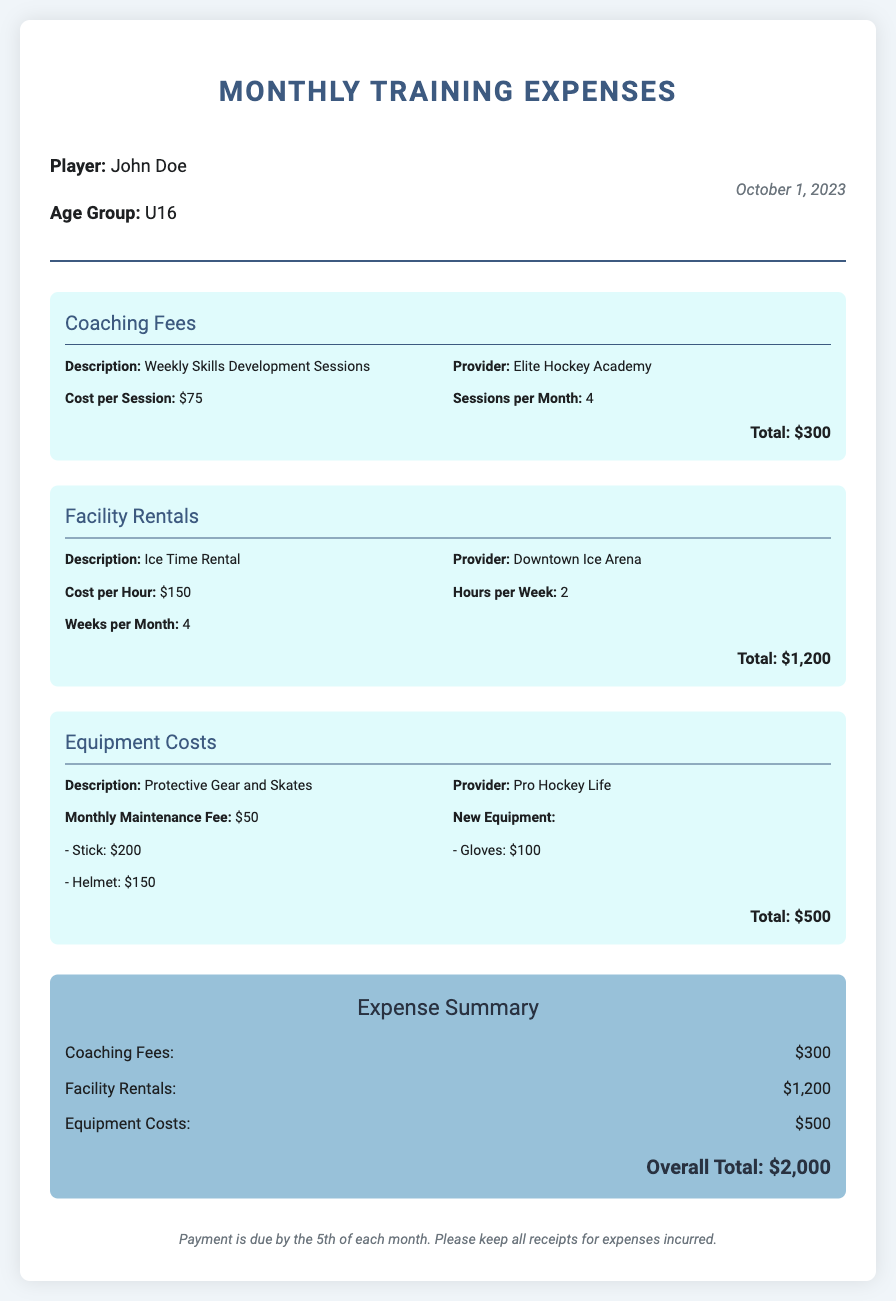What is the player’s name? The document states the player's name in the header section, which is John Doe.
Answer: John Doe What is the age group of the player? The age group is mentioned directly next to the player's name in the document, which is U16.
Answer: U16 What is the cost per session for coaching fees? The document specifies the cost per session for coaching fees as $75.
Answer: $75 How many coaching sessions are there per month? The document indicates that there are 4 coaching sessions per month.
Answer: 4 What is the total cost for facility rentals? The total cost for facility rentals is provided in the expense section as $1,200.
Answer: $1,200 Which provider offers the ice time rental? The document lists Downtown Ice Arena as the provider for ice time rental.
Answer: Downtown Ice Arena What are the monthly maintenance fees for equipment? The document mentions that the monthly maintenance fee for equipment is $50.
Answer: $50 What is the overall total of all expenses? The overall total is calculated and stated in the summary section as $2,000.
Answer: $2,000 When is the payment due? The document includes a note mentioning that payment is due by the 5th of each month.
Answer: 5th of each month 